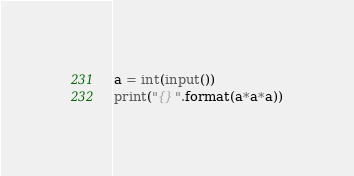Convert code to text. <code><loc_0><loc_0><loc_500><loc_500><_Python_>a = int(input())
print("{}".format(a*a*a))
</code> 